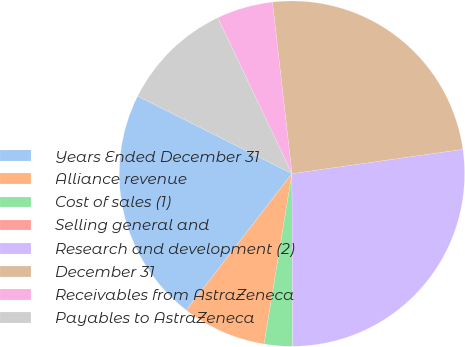Convert chart to OTSL. <chart><loc_0><loc_0><loc_500><loc_500><pie_chart><fcel>Years Ended December 31<fcel>Alliance revenue<fcel>Cost of sales (1)<fcel>Selling general and<fcel>Research and development (2)<fcel>December 31<fcel>Receivables from AstraZeneca<fcel>Payables to AstraZeneca<nl><fcel>21.93%<fcel>7.9%<fcel>2.64%<fcel>0.01%<fcel>27.18%<fcel>24.55%<fcel>5.27%<fcel>10.52%<nl></chart> 